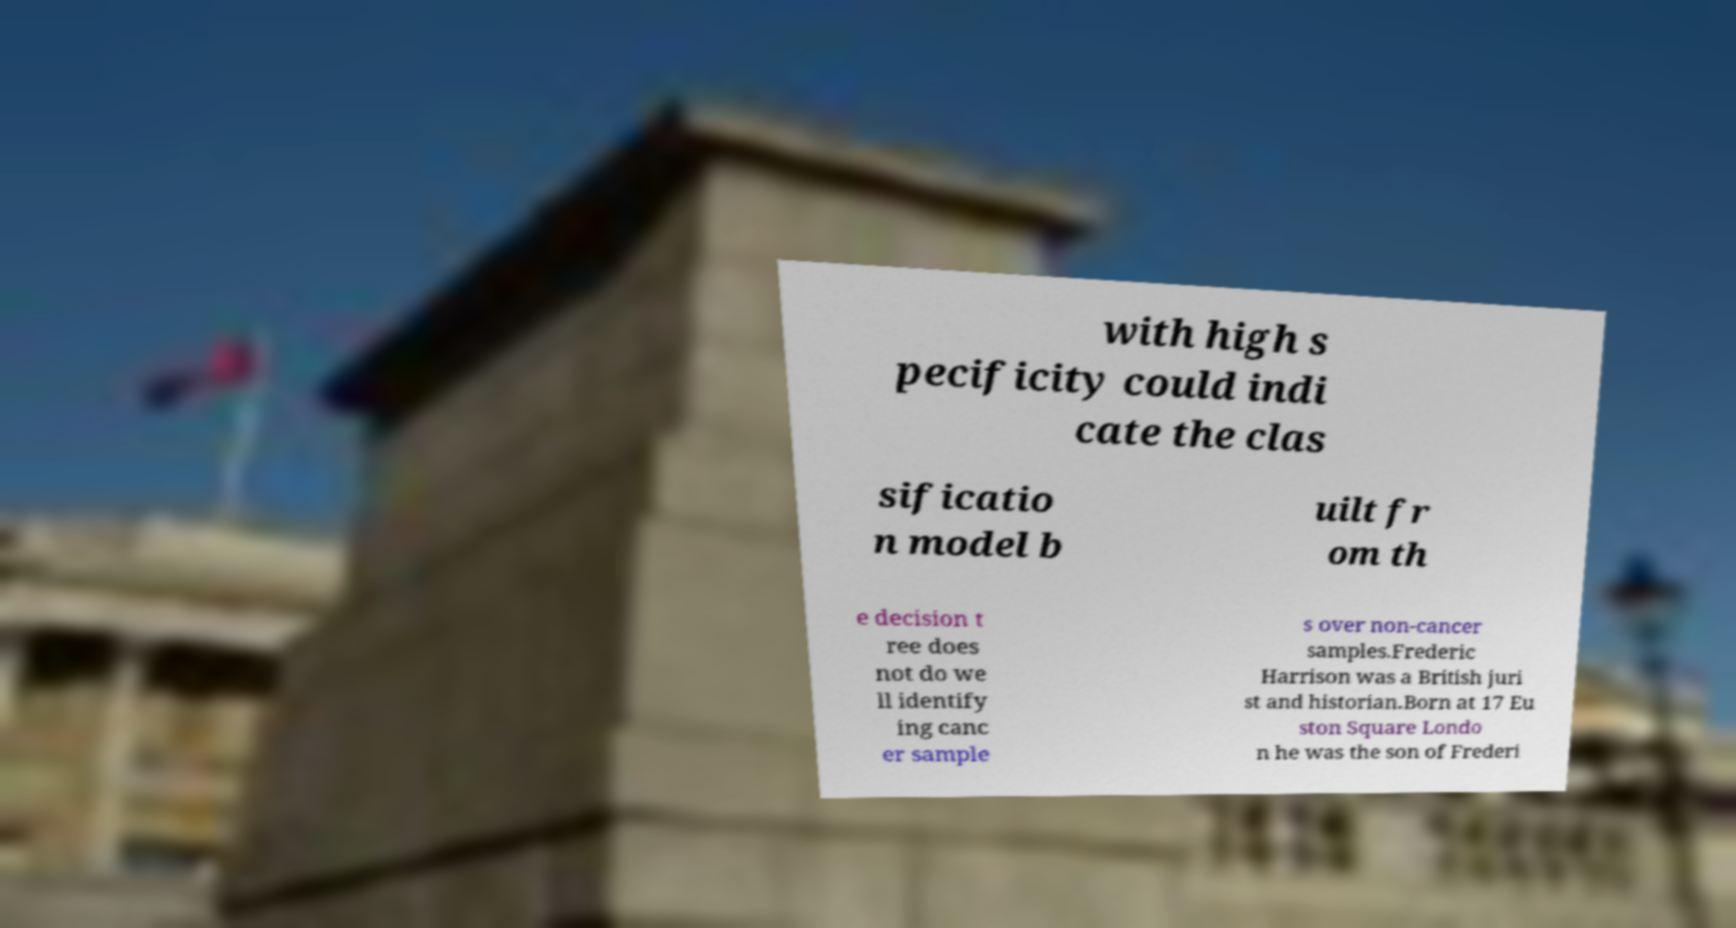Can you read and provide the text displayed in the image?This photo seems to have some interesting text. Can you extract and type it out for me? with high s pecificity could indi cate the clas sificatio n model b uilt fr om th e decision t ree does not do we ll identify ing canc er sample s over non-cancer samples.Frederic Harrison was a British juri st and historian.Born at 17 Eu ston Square Londo n he was the son of Frederi 